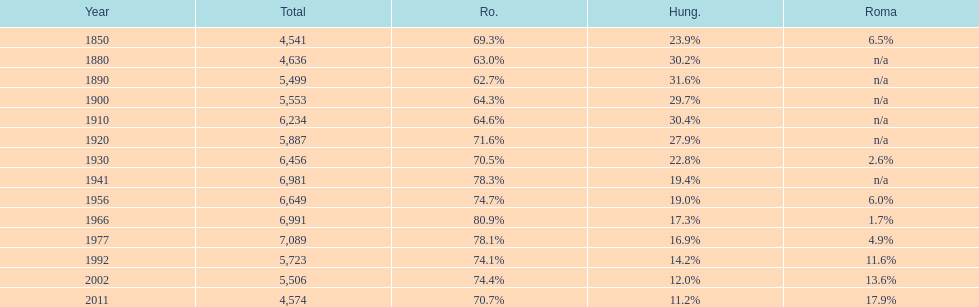Parse the table in full. {'header': ['Year', 'Total', 'Ro.', 'Hung.', 'Roma'], 'rows': [['1850', '4,541', '69.3%', '23.9%', '6.5%'], ['1880', '4,636', '63.0%', '30.2%', 'n/a'], ['1890', '5,499', '62.7%', '31.6%', 'n/a'], ['1900', '5,553', '64.3%', '29.7%', 'n/a'], ['1910', '6,234', '64.6%', '30.4%', 'n/a'], ['1920', '5,887', '71.6%', '27.9%', 'n/a'], ['1930', '6,456', '70.5%', '22.8%', '2.6%'], ['1941', '6,981', '78.3%', '19.4%', 'n/a'], ['1956', '6,649', '74.7%', '19.0%', '6.0%'], ['1966', '6,991', '80.9%', '17.3%', '1.7%'], ['1977', '7,089', '78.1%', '16.9%', '4.9%'], ['1992', '5,723', '74.1%', '14.2%', '11.6%'], ['2002', '5,506', '74.4%', '12.0%', '13.6%'], ['2011', '4,574', '70.7%', '11.2%', '17.9%']]} What percent of the population were romanians according to the last year on this chart? 70.7%. 